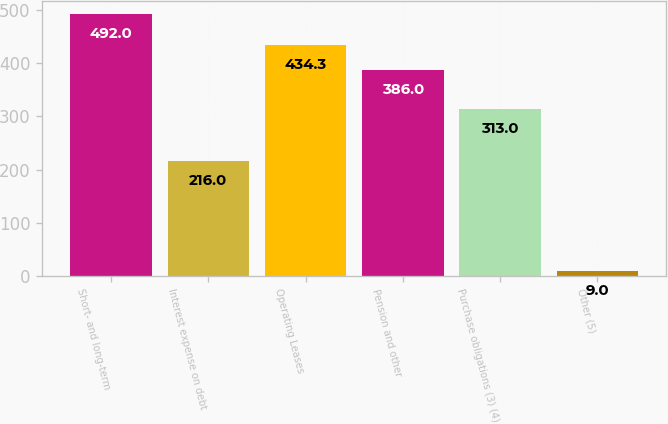Convert chart to OTSL. <chart><loc_0><loc_0><loc_500><loc_500><bar_chart><fcel>Short- and long-term<fcel>Interest expense on debt<fcel>Operating Leases<fcel>Pension and other<fcel>Purchase obligations (3) (4)<fcel>Other (5)<nl><fcel>492<fcel>216<fcel>434.3<fcel>386<fcel>313<fcel>9<nl></chart> 